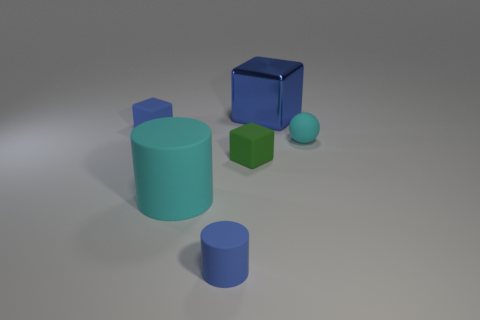Add 2 blue objects. How many objects exist? 8 Subtract all cylinders. How many objects are left? 4 Add 1 large blue metal things. How many large blue metal things are left? 2 Add 2 big blue objects. How many big blue objects exist? 3 Subtract 0 purple spheres. How many objects are left? 6 Subtract all yellow shiny blocks. Subtract all blue matte blocks. How many objects are left? 5 